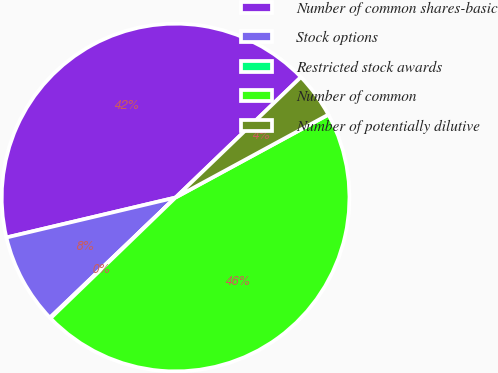<chart> <loc_0><loc_0><loc_500><loc_500><pie_chart><fcel>Number of common shares-basic<fcel>Stock options<fcel>Restricted stock awards<fcel>Number of common<fcel>Number of potentially dilutive<nl><fcel>41.51%<fcel>8.45%<fcel>0.08%<fcel>45.69%<fcel>4.27%<nl></chart> 